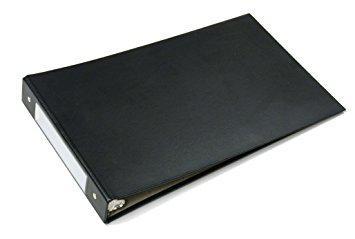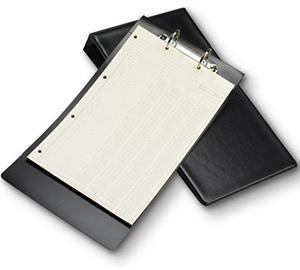The first image is the image on the left, the second image is the image on the right. Assess this claim about the two images: "One image shows a single upright black binder, and the other image shows a paper-filled open binder lying by at least one upright closed binder.". Correct or not? Answer yes or no. No. The first image is the image on the left, the second image is the image on the right. Considering the images on both sides, is "The binder in the image on the right is open to show white pages." valid? Answer yes or no. Yes. 